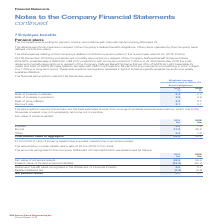According to Spirax Sarco Engineering Plc's financial document, What is the Fair value of scheme’s assets at 2019? According to the financial document, 59.5 (in millions). The relevant text states: "2018 £m Fair value of scheme’s assets 59.5 56.4 Present value of funded scheme’s liabilities (53.9) (52.7) Retirement benefit asset recognised..." Also, What was the actual return on plan assets? a gain of £5.5m (2018: £1.0m loss). The document states: "The actual return on plan assets was a gain of £5.5m (2018: £1.0m loss)...." Also, For which years was the net pension asset calculated for? The document shows two values: 2019 and 2018. From the document: "At 31st December 2019 the post-retirement mortality assumptions in respect of the Company Defined Benefit Scheme follows a long term trend of 1.25% p...." Additionally, In which year was the net pension asset larger? According to the financial document, 2019. The relevant text states: "At 31st December 2019 the post-retirement mortality assumptions in respect of the Company Defined Benefit Scheme follows..." Also, can you calculate: What was the change in net pension asset from 2018 to 2019? Based on the calculation: 4.7-3.1, the result is 1.6 (in millions). This is based on the information: "elated deferred tax (0.9) (0.6) Net pension asset 4.7 3.1 ed deferred tax (0.9) (0.6) Net pension asset 4.7 3.1..." The key data points involved are: 3.1, 4.7. Also, can you calculate: What was the percentage change in net pension asset from 2018 to 2019? To answer this question, I need to perform calculations using the financial data. The calculation is: (4.7-3.1)/3.1, which equals 51.61 (percentage). This is based on the information: "elated deferred tax (0.9) (0.6) Net pension asset 4.7 3.1 ed deferred tax (0.9) (0.6) Net pension asset 4.7 3.1..." The key data points involved are: 3.1, 4.7. 